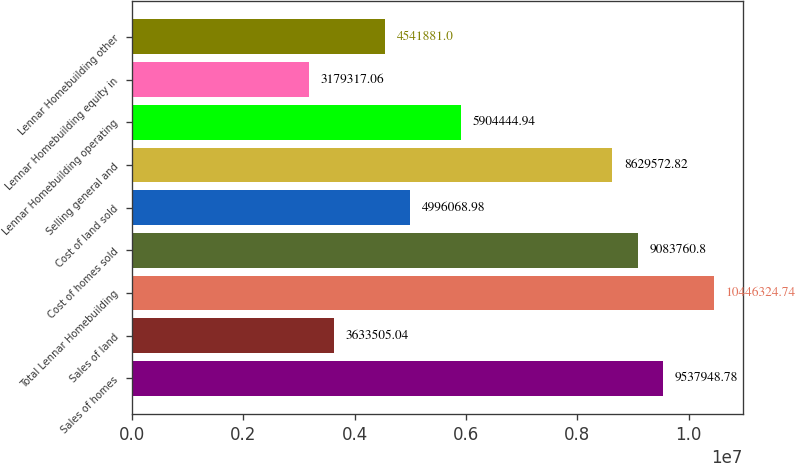Convert chart. <chart><loc_0><loc_0><loc_500><loc_500><bar_chart><fcel>Sales of homes<fcel>Sales of land<fcel>Total Lennar Homebuilding<fcel>Cost of homes sold<fcel>Cost of land sold<fcel>Selling general and<fcel>Lennar Homebuilding operating<fcel>Lennar Homebuilding equity in<fcel>Lennar Homebuilding other<nl><fcel>9.53795e+06<fcel>3.63351e+06<fcel>1.04463e+07<fcel>9.08376e+06<fcel>4.99607e+06<fcel>8.62957e+06<fcel>5.90444e+06<fcel>3.17932e+06<fcel>4.54188e+06<nl></chart> 